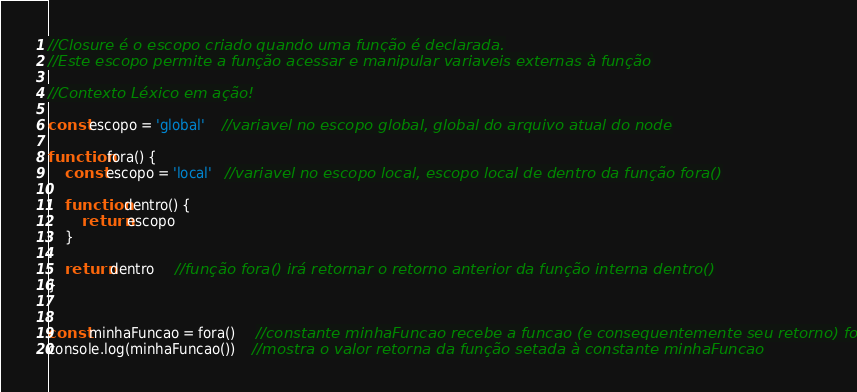Convert code to text. <code><loc_0><loc_0><loc_500><loc_500><_JavaScript_>
//Closure é o escopo criado quando uma função é declarada.
//Este escopo permite a função acessar e manipular variaveis externas à função

//Contexto Léxico em ação!

const escopo = 'global'    //variavel no escopo global, global do arquivo atual do node

function fora() {
    const escopo = 'local'   //variavel no escopo local, escopo local de dentro da função fora()

    function dentro() {
        return escopo
    }

    return dentro     //função fora() irá retornar o retorno anterior da função interna dentro()
}


const minhaFuncao = fora()     //constante minhaFuncao recebe a funcao (e consequentemente seu retorno) fora()
console.log(minhaFuncao())    //mostra o valor retorna da função setada à constante minhaFuncao







</code> 